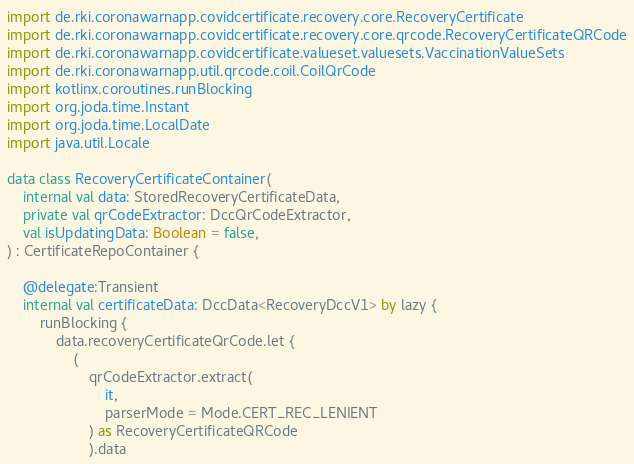Convert code to text. <code><loc_0><loc_0><loc_500><loc_500><_Kotlin_>import de.rki.coronawarnapp.covidcertificate.recovery.core.RecoveryCertificate
import de.rki.coronawarnapp.covidcertificate.recovery.core.qrcode.RecoveryCertificateQRCode
import de.rki.coronawarnapp.covidcertificate.valueset.valuesets.VaccinationValueSets
import de.rki.coronawarnapp.util.qrcode.coil.CoilQrCode
import kotlinx.coroutines.runBlocking
import org.joda.time.Instant
import org.joda.time.LocalDate
import java.util.Locale

data class RecoveryCertificateContainer(
    internal val data: StoredRecoveryCertificateData,
    private val qrCodeExtractor: DccQrCodeExtractor,
    val isUpdatingData: Boolean = false,
) : CertificateRepoContainer {

    @delegate:Transient
    internal val certificateData: DccData<RecoveryDccV1> by lazy {
        runBlocking {
            data.recoveryCertificateQrCode.let {
                (
                    qrCodeExtractor.extract(
                        it,
                        parserMode = Mode.CERT_REC_LENIENT
                    ) as RecoveryCertificateQRCode
                    ).data</code> 